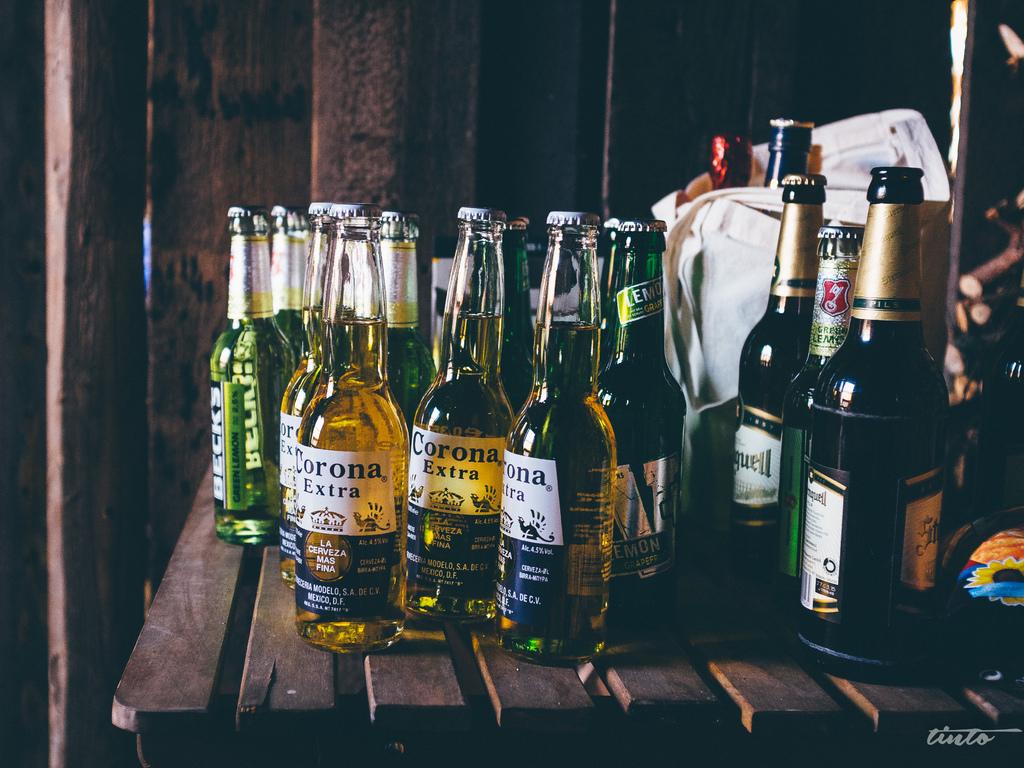What brand is the beer in the green bottle?
Ensure brevity in your answer.  Becks. 